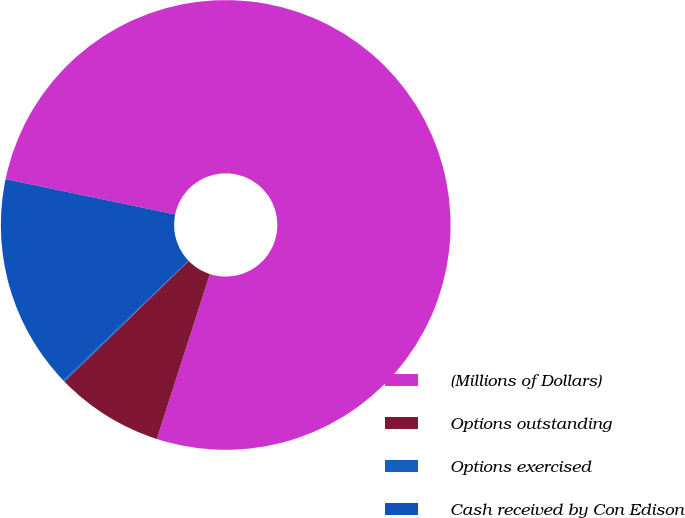Convert chart. <chart><loc_0><loc_0><loc_500><loc_500><pie_chart><fcel>(Millions of Dollars)<fcel>Options outstanding<fcel>Options exercised<fcel>Cash received by Con Edison<nl><fcel>76.69%<fcel>7.77%<fcel>0.11%<fcel>15.43%<nl></chart> 